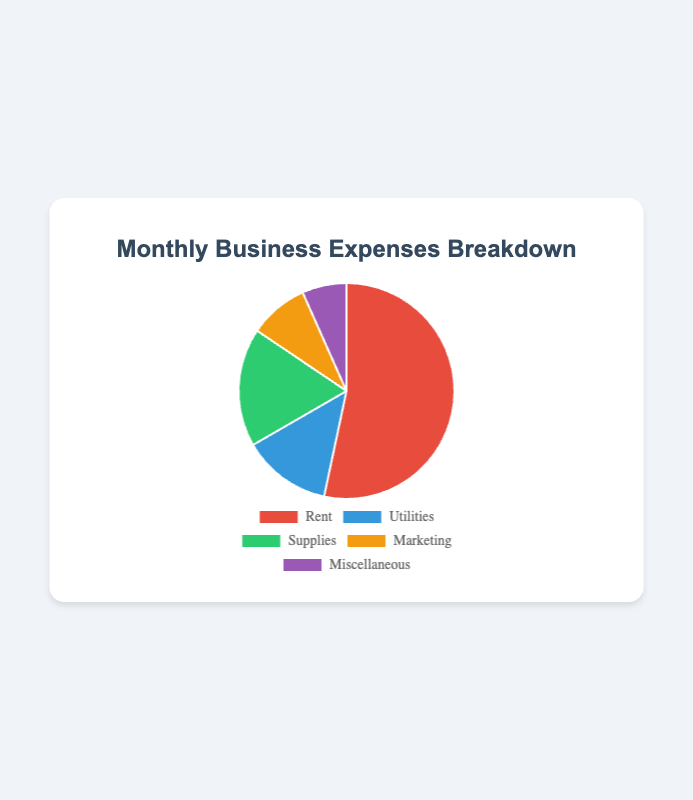Does the Rent category have the highest expense? The pie chart shows the Monthly Business Expenses Breakdown, where each category's proportion is visible. The Rent section is the largest among the categories, indicating it has the highest expense.
Answer: Yes How much more is spent on Rent compared to Marketing? The amount spent on Rent is £1200 and on Marketing is £200. The difference is found by subtracting the Marketing expense from the Rent expense: £1200 - £200 = £1000.
Answer: £1000 What is the total amount spent on all expenses? We add up all the amounts for each category: £1200 (Rent) + £300 (Utilities) + £400 (Supplies) + £200 (Marketing) + £150 (Miscellaneous). The sum is: £1200 + £300 + £400 + £200 + £150 = £2250.
Answer: £2250 Which category has the lowest expense? The pie chart shows different categories with varying proportions. The smallest section belongs to Miscellaneous, indicating it has the lowest expense amount of £150.
Answer: Miscellaneous How much more is spent on Utilities and Supplies together compared to Marketing and Miscellaneous together? First, sum the expenses for Utilities and Supplies: £300 (Utilities) + £400 (Supplies) = £700. Then, sum the expenses for Marketing and Miscellaneous: £200 (Marketing) + £150 (Miscellaneous) = £350. Finally, find the difference: £700 - £350 = £350.
Answer: £350 What percentage of the total expenses is allocated to Rent? The total amount spent on all expenses is £2250. The amount spent on Rent is £1200. The percentage is calculated by (Rent / Total) * 100 = (£1200 / £2250) * 100 ≈ 53.33%.
Answer: 53.33% Is the amount spent on Supplies greater than the amount spent on Utilities and Marketing combined? First, sum the expenses for Utilities and Marketing: £300 (Utilities) + £200 (Marketing) = £500. The expense for Supplies is £400. Since £400 (Supplies) is not greater than £500 (Utilities and Marketing combined), the answer is no.
Answer: No 